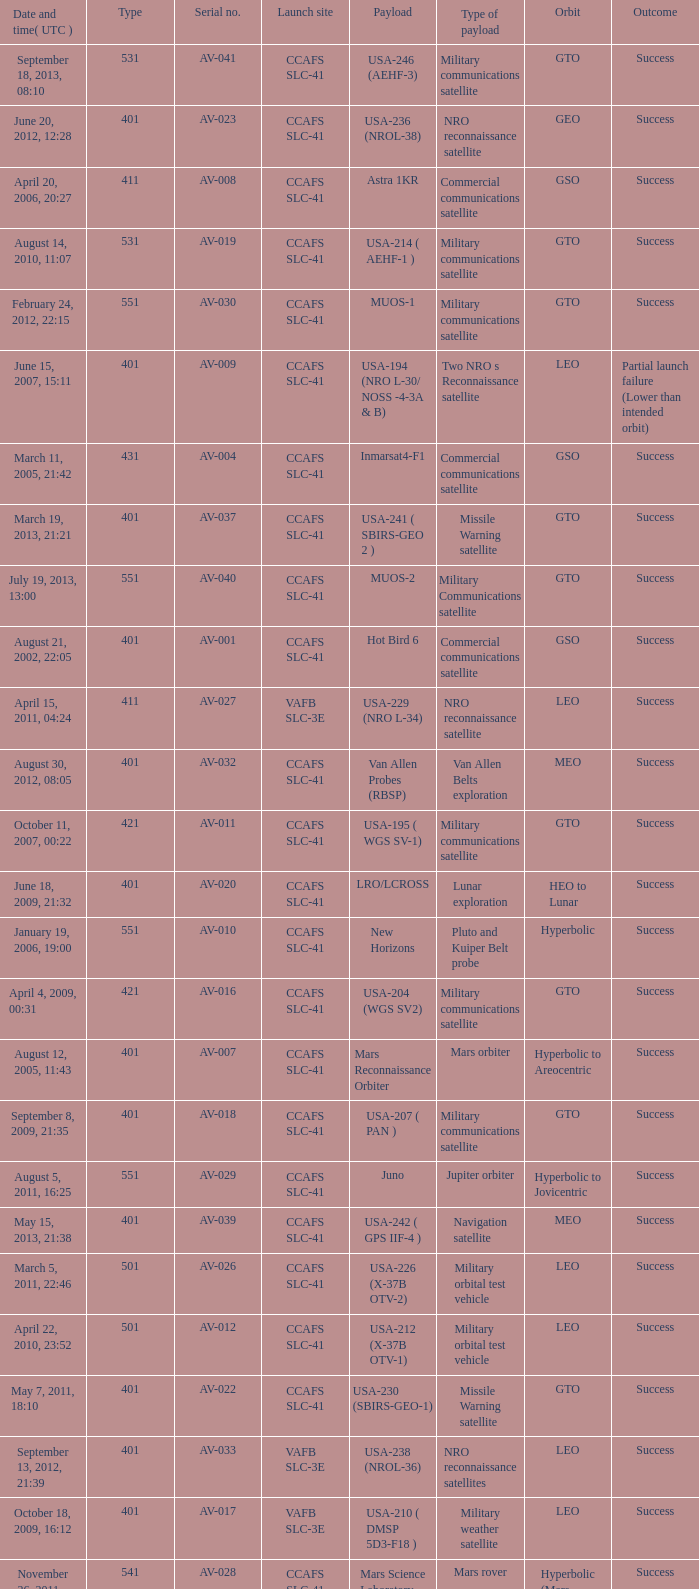What payload was on November 26, 2011, 15:02? Mars rover. 